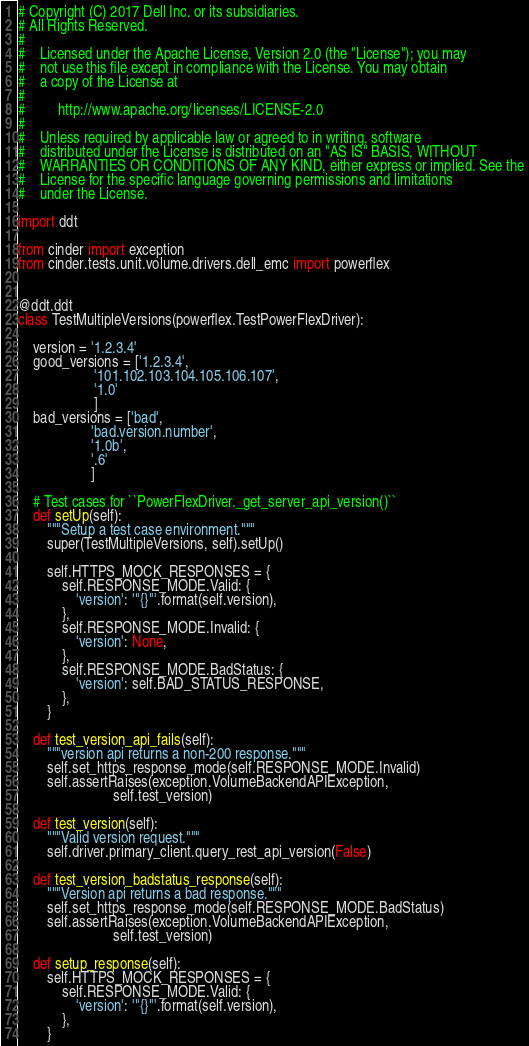<code> <loc_0><loc_0><loc_500><loc_500><_Python_># Copyright (C) 2017 Dell Inc. or its subsidiaries.
# All Rights Reserved.
#
#    Licensed under the Apache License, Version 2.0 (the "License"); you may
#    not use this file except in compliance with the License. You may obtain
#    a copy of the License at
#
#         http://www.apache.org/licenses/LICENSE-2.0
#
#    Unless required by applicable law or agreed to in writing, software
#    distributed under the License is distributed on an "AS IS" BASIS, WITHOUT
#    WARRANTIES OR CONDITIONS OF ANY KIND, either express or implied. See the
#    License for the specific language governing permissions and limitations
#    under the License.

import ddt

from cinder import exception
from cinder.tests.unit.volume.drivers.dell_emc import powerflex


@ddt.ddt
class TestMultipleVersions(powerflex.TestPowerFlexDriver):

    version = '1.2.3.4'
    good_versions = ['1.2.3.4',
                     '101.102.103.104.105.106.107',
                     '1.0'
                     ]
    bad_versions = ['bad',
                    'bad.version.number',
                    '1.0b',
                    '.6'
                    ]

    # Test cases for ``PowerFlexDriver._get_server_api_version()``
    def setUp(self):
        """Setup a test case environment."""
        super(TestMultipleVersions, self).setUp()

        self.HTTPS_MOCK_RESPONSES = {
            self.RESPONSE_MODE.Valid: {
                'version': '"{}"'.format(self.version),
            },
            self.RESPONSE_MODE.Invalid: {
                'version': None,
            },
            self.RESPONSE_MODE.BadStatus: {
                'version': self.BAD_STATUS_RESPONSE,
            },
        }

    def test_version_api_fails(self):
        """version api returns a non-200 response."""
        self.set_https_response_mode(self.RESPONSE_MODE.Invalid)
        self.assertRaises(exception.VolumeBackendAPIException,
                          self.test_version)

    def test_version(self):
        """Valid version request."""
        self.driver.primary_client.query_rest_api_version(False)

    def test_version_badstatus_response(self):
        """Version api returns a bad response."""
        self.set_https_response_mode(self.RESPONSE_MODE.BadStatus)
        self.assertRaises(exception.VolumeBackendAPIException,
                          self.test_version)

    def setup_response(self):
        self.HTTPS_MOCK_RESPONSES = {
            self.RESPONSE_MODE.Valid: {
                'version': '"{}"'.format(self.version),
            },
        }
</code> 